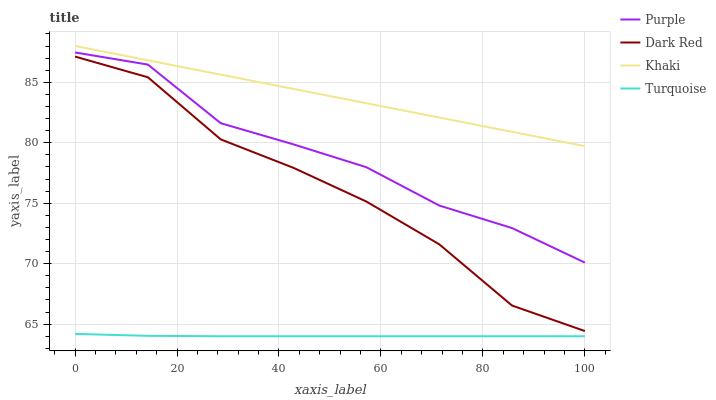Does Turquoise have the minimum area under the curve?
Answer yes or no. Yes. Does Khaki have the maximum area under the curve?
Answer yes or no. Yes. Does Dark Red have the minimum area under the curve?
Answer yes or no. No. Does Dark Red have the maximum area under the curve?
Answer yes or no. No. Is Khaki the smoothest?
Answer yes or no. Yes. Is Dark Red the roughest?
Answer yes or no. Yes. Is Turquoise the smoothest?
Answer yes or no. No. Is Turquoise the roughest?
Answer yes or no. No. Does Turquoise have the lowest value?
Answer yes or no. Yes. Does Dark Red have the lowest value?
Answer yes or no. No. Does Khaki have the highest value?
Answer yes or no. Yes. Does Dark Red have the highest value?
Answer yes or no. No. Is Dark Red less than Khaki?
Answer yes or no. Yes. Is Khaki greater than Dark Red?
Answer yes or no. Yes. Does Dark Red intersect Khaki?
Answer yes or no. No. 